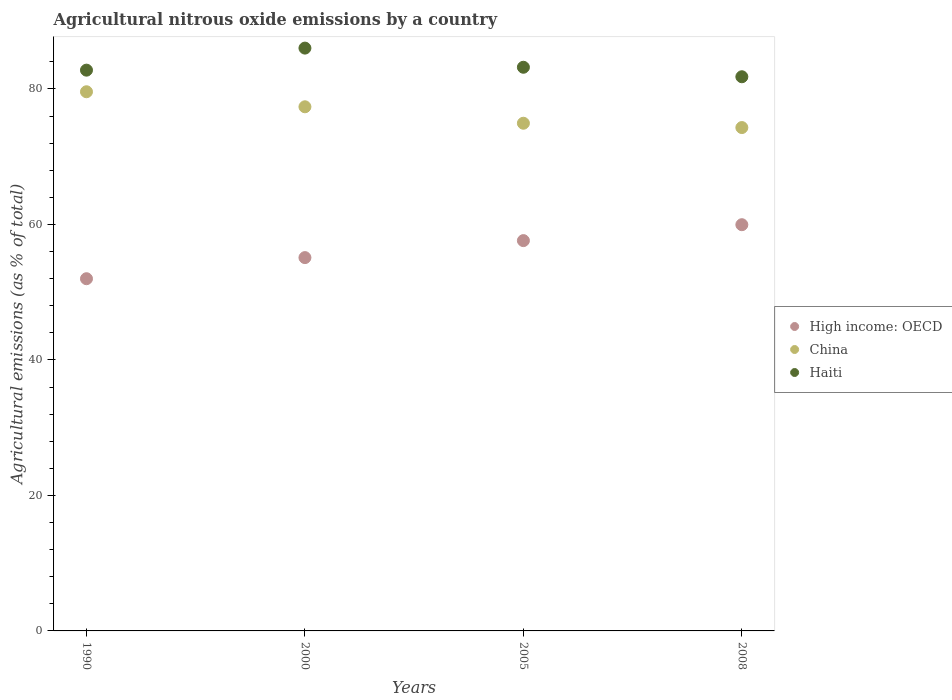How many different coloured dotlines are there?
Your answer should be compact. 3. What is the amount of agricultural nitrous oxide emitted in China in 2008?
Give a very brief answer. 74.3. Across all years, what is the maximum amount of agricultural nitrous oxide emitted in Haiti?
Your answer should be compact. 86.03. Across all years, what is the minimum amount of agricultural nitrous oxide emitted in China?
Offer a terse response. 74.3. In which year was the amount of agricultural nitrous oxide emitted in Haiti maximum?
Your answer should be very brief. 2000. In which year was the amount of agricultural nitrous oxide emitted in Haiti minimum?
Make the answer very short. 2008. What is the total amount of agricultural nitrous oxide emitted in Haiti in the graph?
Your answer should be compact. 333.81. What is the difference between the amount of agricultural nitrous oxide emitted in China in 1990 and that in 2000?
Your answer should be very brief. 2.22. What is the difference between the amount of agricultural nitrous oxide emitted in China in 1990 and the amount of agricultural nitrous oxide emitted in High income: OECD in 2008?
Offer a very short reply. 19.62. What is the average amount of agricultural nitrous oxide emitted in China per year?
Keep it short and to the point. 76.55. In the year 1990, what is the difference between the amount of agricultural nitrous oxide emitted in High income: OECD and amount of agricultural nitrous oxide emitted in China?
Keep it short and to the point. -27.6. In how many years, is the amount of agricultural nitrous oxide emitted in High income: OECD greater than 32 %?
Offer a terse response. 4. What is the ratio of the amount of agricultural nitrous oxide emitted in High income: OECD in 1990 to that in 2000?
Offer a very short reply. 0.94. Is the difference between the amount of agricultural nitrous oxide emitted in High income: OECD in 2000 and 2008 greater than the difference between the amount of agricultural nitrous oxide emitted in China in 2000 and 2008?
Give a very brief answer. No. What is the difference between the highest and the second highest amount of agricultural nitrous oxide emitted in Haiti?
Make the answer very short. 2.83. What is the difference between the highest and the lowest amount of agricultural nitrous oxide emitted in Haiti?
Your answer should be very brief. 4.23. Is the sum of the amount of agricultural nitrous oxide emitted in China in 2000 and 2008 greater than the maximum amount of agricultural nitrous oxide emitted in High income: OECD across all years?
Offer a very short reply. Yes. Does the amount of agricultural nitrous oxide emitted in Haiti monotonically increase over the years?
Provide a succinct answer. No. Is the amount of agricultural nitrous oxide emitted in Haiti strictly greater than the amount of agricultural nitrous oxide emitted in High income: OECD over the years?
Ensure brevity in your answer.  Yes. Is the amount of agricultural nitrous oxide emitted in High income: OECD strictly less than the amount of agricultural nitrous oxide emitted in China over the years?
Offer a very short reply. Yes. How many years are there in the graph?
Your response must be concise. 4. What is the difference between two consecutive major ticks on the Y-axis?
Offer a terse response. 20. Does the graph contain grids?
Provide a succinct answer. No. Where does the legend appear in the graph?
Your answer should be very brief. Center right. How many legend labels are there?
Provide a succinct answer. 3. How are the legend labels stacked?
Provide a short and direct response. Vertical. What is the title of the graph?
Your answer should be compact. Agricultural nitrous oxide emissions by a country. Does "Swaziland" appear as one of the legend labels in the graph?
Offer a very short reply. No. What is the label or title of the Y-axis?
Ensure brevity in your answer.  Agricultural emissions (as % of total). What is the Agricultural emissions (as % of total) of High income: OECD in 1990?
Offer a terse response. 51.99. What is the Agricultural emissions (as % of total) of China in 1990?
Your answer should be very brief. 79.59. What is the Agricultural emissions (as % of total) of Haiti in 1990?
Provide a succinct answer. 82.77. What is the Agricultural emissions (as % of total) of High income: OECD in 2000?
Your answer should be compact. 55.1. What is the Agricultural emissions (as % of total) of China in 2000?
Offer a terse response. 77.37. What is the Agricultural emissions (as % of total) in Haiti in 2000?
Give a very brief answer. 86.03. What is the Agricultural emissions (as % of total) of High income: OECD in 2005?
Ensure brevity in your answer.  57.61. What is the Agricultural emissions (as % of total) in China in 2005?
Offer a terse response. 74.94. What is the Agricultural emissions (as % of total) in Haiti in 2005?
Provide a succinct answer. 83.2. What is the Agricultural emissions (as % of total) of High income: OECD in 2008?
Offer a terse response. 59.96. What is the Agricultural emissions (as % of total) of China in 2008?
Give a very brief answer. 74.3. What is the Agricultural emissions (as % of total) in Haiti in 2008?
Your response must be concise. 81.8. Across all years, what is the maximum Agricultural emissions (as % of total) in High income: OECD?
Ensure brevity in your answer.  59.96. Across all years, what is the maximum Agricultural emissions (as % of total) of China?
Offer a very short reply. 79.59. Across all years, what is the maximum Agricultural emissions (as % of total) of Haiti?
Your answer should be very brief. 86.03. Across all years, what is the minimum Agricultural emissions (as % of total) of High income: OECD?
Provide a short and direct response. 51.99. Across all years, what is the minimum Agricultural emissions (as % of total) of China?
Provide a short and direct response. 74.3. Across all years, what is the minimum Agricultural emissions (as % of total) of Haiti?
Your answer should be compact. 81.8. What is the total Agricultural emissions (as % of total) in High income: OECD in the graph?
Offer a terse response. 224.67. What is the total Agricultural emissions (as % of total) in China in the graph?
Ensure brevity in your answer.  306.19. What is the total Agricultural emissions (as % of total) of Haiti in the graph?
Provide a short and direct response. 333.81. What is the difference between the Agricultural emissions (as % of total) in High income: OECD in 1990 and that in 2000?
Offer a terse response. -3.12. What is the difference between the Agricultural emissions (as % of total) of China in 1990 and that in 2000?
Give a very brief answer. 2.22. What is the difference between the Agricultural emissions (as % of total) of Haiti in 1990 and that in 2000?
Provide a short and direct response. -3.25. What is the difference between the Agricultural emissions (as % of total) of High income: OECD in 1990 and that in 2005?
Offer a very short reply. -5.62. What is the difference between the Agricultural emissions (as % of total) of China in 1990 and that in 2005?
Your answer should be compact. 4.65. What is the difference between the Agricultural emissions (as % of total) in Haiti in 1990 and that in 2005?
Offer a very short reply. -0.43. What is the difference between the Agricultural emissions (as % of total) in High income: OECD in 1990 and that in 2008?
Give a very brief answer. -7.97. What is the difference between the Agricultural emissions (as % of total) in China in 1990 and that in 2008?
Keep it short and to the point. 5.29. What is the difference between the Agricultural emissions (as % of total) in Haiti in 1990 and that in 2008?
Ensure brevity in your answer.  0.97. What is the difference between the Agricultural emissions (as % of total) of High income: OECD in 2000 and that in 2005?
Ensure brevity in your answer.  -2.51. What is the difference between the Agricultural emissions (as % of total) in China in 2000 and that in 2005?
Ensure brevity in your answer.  2.43. What is the difference between the Agricultural emissions (as % of total) in Haiti in 2000 and that in 2005?
Keep it short and to the point. 2.83. What is the difference between the Agricultural emissions (as % of total) of High income: OECD in 2000 and that in 2008?
Provide a short and direct response. -4.86. What is the difference between the Agricultural emissions (as % of total) of China in 2000 and that in 2008?
Provide a short and direct response. 3.07. What is the difference between the Agricultural emissions (as % of total) of Haiti in 2000 and that in 2008?
Give a very brief answer. 4.23. What is the difference between the Agricultural emissions (as % of total) in High income: OECD in 2005 and that in 2008?
Your answer should be very brief. -2.35. What is the difference between the Agricultural emissions (as % of total) in China in 2005 and that in 2008?
Your answer should be very brief. 0.64. What is the difference between the Agricultural emissions (as % of total) in Haiti in 2005 and that in 2008?
Ensure brevity in your answer.  1.4. What is the difference between the Agricultural emissions (as % of total) in High income: OECD in 1990 and the Agricultural emissions (as % of total) in China in 2000?
Offer a very short reply. -25.38. What is the difference between the Agricultural emissions (as % of total) in High income: OECD in 1990 and the Agricultural emissions (as % of total) in Haiti in 2000?
Your answer should be very brief. -34.04. What is the difference between the Agricultural emissions (as % of total) of China in 1990 and the Agricultural emissions (as % of total) of Haiti in 2000?
Provide a short and direct response. -6.44. What is the difference between the Agricultural emissions (as % of total) in High income: OECD in 1990 and the Agricultural emissions (as % of total) in China in 2005?
Your answer should be compact. -22.95. What is the difference between the Agricultural emissions (as % of total) of High income: OECD in 1990 and the Agricultural emissions (as % of total) of Haiti in 2005?
Provide a short and direct response. -31.21. What is the difference between the Agricultural emissions (as % of total) in China in 1990 and the Agricultural emissions (as % of total) in Haiti in 2005?
Ensure brevity in your answer.  -3.62. What is the difference between the Agricultural emissions (as % of total) of High income: OECD in 1990 and the Agricultural emissions (as % of total) of China in 2008?
Your answer should be compact. -22.31. What is the difference between the Agricultural emissions (as % of total) of High income: OECD in 1990 and the Agricultural emissions (as % of total) of Haiti in 2008?
Your answer should be compact. -29.81. What is the difference between the Agricultural emissions (as % of total) in China in 1990 and the Agricultural emissions (as % of total) in Haiti in 2008?
Keep it short and to the point. -2.21. What is the difference between the Agricultural emissions (as % of total) of High income: OECD in 2000 and the Agricultural emissions (as % of total) of China in 2005?
Provide a succinct answer. -19.83. What is the difference between the Agricultural emissions (as % of total) in High income: OECD in 2000 and the Agricultural emissions (as % of total) in Haiti in 2005?
Provide a short and direct response. -28.1. What is the difference between the Agricultural emissions (as % of total) of China in 2000 and the Agricultural emissions (as % of total) of Haiti in 2005?
Offer a terse response. -5.84. What is the difference between the Agricultural emissions (as % of total) of High income: OECD in 2000 and the Agricultural emissions (as % of total) of China in 2008?
Keep it short and to the point. -19.2. What is the difference between the Agricultural emissions (as % of total) in High income: OECD in 2000 and the Agricultural emissions (as % of total) in Haiti in 2008?
Give a very brief answer. -26.7. What is the difference between the Agricultural emissions (as % of total) in China in 2000 and the Agricultural emissions (as % of total) in Haiti in 2008?
Provide a succinct answer. -4.43. What is the difference between the Agricultural emissions (as % of total) in High income: OECD in 2005 and the Agricultural emissions (as % of total) in China in 2008?
Keep it short and to the point. -16.69. What is the difference between the Agricultural emissions (as % of total) of High income: OECD in 2005 and the Agricultural emissions (as % of total) of Haiti in 2008?
Offer a terse response. -24.19. What is the difference between the Agricultural emissions (as % of total) in China in 2005 and the Agricultural emissions (as % of total) in Haiti in 2008?
Ensure brevity in your answer.  -6.86. What is the average Agricultural emissions (as % of total) in High income: OECD per year?
Your response must be concise. 56.17. What is the average Agricultural emissions (as % of total) of China per year?
Your answer should be compact. 76.55. What is the average Agricultural emissions (as % of total) of Haiti per year?
Ensure brevity in your answer.  83.45. In the year 1990, what is the difference between the Agricultural emissions (as % of total) in High income: OECD and Agricultural emissions (as % of total) in China?
Make the answer very short. -27.6. In the year 1990, what is the difference between the Agricultural emissions (as % of total) of High income: OECD and Agricultural emissions (as % of total) of Haiti?
Your answer should be very brief. -30.79. In the year 1990, what is the difference between the Agricultural emissions (as % of total) in China and Agricultural emissions (as % of total) in Haiti?
Your answer should be very brief. -3.19. In the year 2000, what is the difference between the Agricultural emissions (as % of total) in High income: OECD and Agricultural emissions (as % of total) in China?
Your answer should be compact. -22.26. In the year 2000, what is the difference between the Agricultural emissions (as % of total) of High income: OECD and Agricultural emissions (as % of total) of Haiti?
Ensure brevity in your answer.  -30.92. In the year 2000, what is the difference between the Agricultural emissions (as % of total) in China and Agricultural emissions (as % of total) in Haiti?
Offer a very short reply. -8.66. In the year 2005, what is the difference between the Agricultural emissions (as % of total) of High income: OECD and Agricultural emissions (as % of total) of China?
Your response must be concise. -17.33. In the year 2005, what is the difference between the Agricultural emissions (as % of total) in High income: OECD and Agricultural emissions (as % of total) in Haiti?
Make the answer very short. -25.59. In the year 2005, what is the difference between the Agricultural emissions (as % of total) in China and Agricultural emissions (as % of total) in Haiti?
Provide a short and direct response. -8.26. In the year 2008, what is the difference between the Agricultural emissions (as % of total) of High income: OECD and Agricultural emissions (as % of total) of China?
Give a very brief answer. -14.34. In the year 2008, what is the difference between the Agricultural emissions (as % of total) in High income: OECD and Agricultural emissions (as % of total) in Haiti?
Give a very brief answer. -21.84. In the year 2008, what is the difference between the Agricultural emissions (as % of total) of China and Agricultural emissions (as % of total) of Haiti?
Offer a terse response. -7.5. What is the ratio of the Agricultural emissions (as % of total) of High income: OECD in 1990 to that in 2000?
Provide a succinct answer. 0.94. What is the ratio of the Agricultural emissions (as % of total) in China in 1990 to that in 2000?
Your response must be concise. 1.03. What is the ratio of the Agricultural emissions (as % of total) in Haiti in 1990 to that in 2000?
Keep it short and to the point. 0.96. What is the ratio of the Agricultural emissions (as % of total) of High income: OECD in 1990 to that in 2005?
Your response must be concise. 0.9. What is the ratio of the Agricultural emissions (as % of total) in China in 1990 to that in 2005?
Ensure brevity in your answer.  1.06. What is the ratio of the Agricultural emissions (as % of total) of Haiti in 1990 to that in 2005?
Offer a very short reply. 0.99. What is the ratio of the Agricultural emissions (as % of total) in High income: OECD in 1990 to that in 2008?
Your answer should be very brief. 0.87. What is the ratio of the Agricultural emissions (as % of total) of China in 1990 to that in 2008?
Give a very brief answer. 1.07. What is the ratio of the Agricultural emissions (as % of total) of Haiti in 1990 to that in 2008?
Give a very brief answer. 1.01. What is the ratio of the Agricultural emissions (as % of total) of High income: OECD in 2000 to that in 2005?
Your answer should be compact. 0.96. What is the ratio of the Agricultural emissions (as % of total) of China in 2000 to that in 2005?
Ensure brevity in your answer.  1.03. What is the ratio of the Agricultural emissions (as % of total) of Haiti in 2000 to that in 2005?
Your response must be concise. 1.03. What is the ratio of the Agricultural emissions (as % of total) in High income: OECD in 2000 to that in 2008?
Offer a very short reply. 0.92. What is the ratio of the Agricultural emissions (as % of total) of China in 2000 to that in 2008?
Provide a short and direct response. 1.04. What is the ratio of the Agricultural emissions (as % of total) in Haiti in 2000 to that in 2008?
Provide a short and direct response. 1.05. What is the ratio of the Agricultural emissions (as % of total) of High income: OECD in 2005 to that in 2008?
Offer a very short reply. 0.96. What is the ratio of the Agricultural emissions (as % of total) in China in 2005 to that in 2008?
Keep it short and to the point. 1.01. What is the ratio of the Agricultural emissions (as % of total) of Haiti in 2005 to that in 2008?
Your response must be concise. 1.02. What is the difference between the highest and the second highest Agricultural emissions (as % of total) of High income: OECD?
Offer a very short reply. 2.35. What is the difference between the highest and the second highest Agricultural emissions (as % of total) in China?
Offer a terse response. 2.22. What is the difference between the highest and the second highest Agricultural emissions (as % of total) of Haiti?
Make the answer very short. 2.83. What is the difference between the highest and the lowest Agricultural emissions (as % of total) of High income: OECD?
Provide a succinct answer. 7.97. What is the difference between the highest and the lowest Agricultural emissions (as % of total) in China?
Your answer should be compact. 5.29. What is the difference between the highest and the lowest Agricultural emissions (as % of total) of Haiti?
Keep it short and to the point. 4.23. 